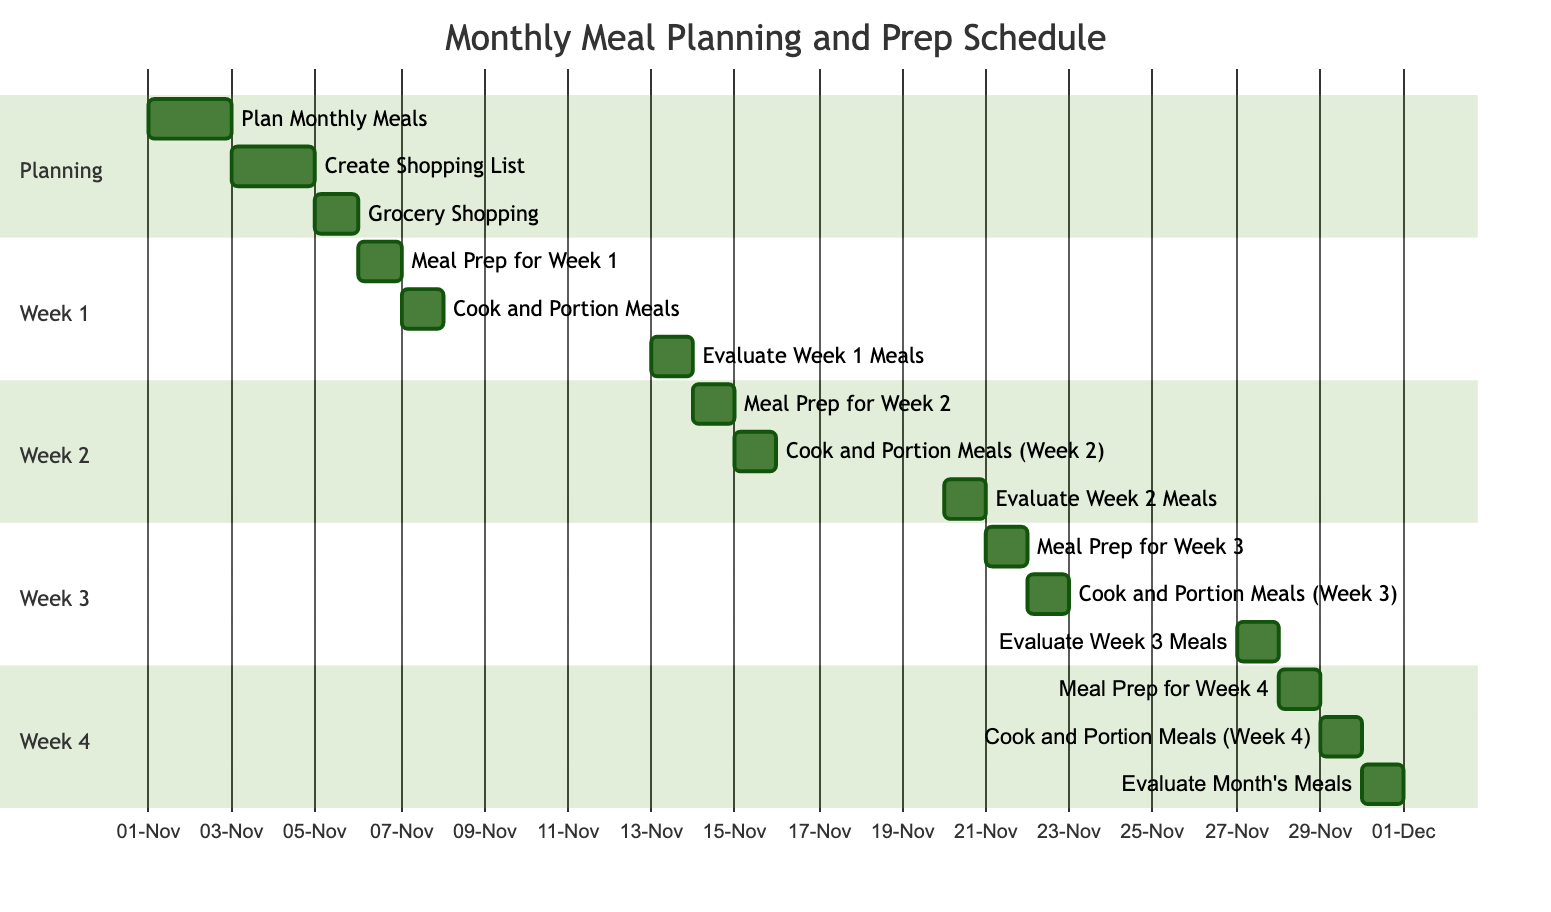What is the duration of the "Plan Monthly Meals" task? The "Plan Monthly Meals" task has a specified duration of "2 days" in the Gantt chart, which shows the start and end dates for this task.
Answer: 2 days How many tasks are planned for Week 3? In the Gantt chart, under Week 3, there are three tasks listed: "Meal Prep for Week 3," "Cook and Portion Meals (Week 3)," and "Evaluate Week 3 Meals." Therefore, the total number of tasks for Week 3 is three.
Answer: 3 What is the end date of the "Cook and Portion Meals (Week 2)" task? The "Cook and Portion Meals (Week 2)" task has an end date of "2023-11-15," which is shown explicitly in the task details in the Gantt chart.
Answer: 2023-11-15 Which task occurs immediately before the "Evaluate Week 2 Meals" task? To determine which task occurs immediately before "Evaluate Week 2 Meals," we can look at the order in the chart. The task before it is "Cook and Portion Meals (Week 2)," which is scheduled for "2023-11-15."
Answer: Cook and Portion Meals (Week 2) What is the first task in the planning section? The first task listed in the planning section of the Gantt chart is "Plan Monthly Meals," as indicated in the task order.
Answer: Plan Monthly Meals How many total meal prep tasks are scheduled in the Gantt chart? By reviewing the chart, there are a total of four meal prep tasks scheduled: one for each week (Week 1, Week 2, Week 3, and Week 4). Therefore, the total number of meal prep tasks is four.
Answer: 4 What is the overall duration of the entire meal prep schedule? The meal prep schedule starts on "2023-11-01" with the planning phase and ends on "2023-11-30" with the evaluation of the month's meals. Calculating the duration from start to end gives us a total duration of 30 days.
Answer: 30 days Which task has the longest duration in the Gantt chart? Based on the provided data, the task "Plan Monthly Meals" has the longest duration of "2 days," as it's the only task with more than one day of scheduled time.
Answer: 2 days 